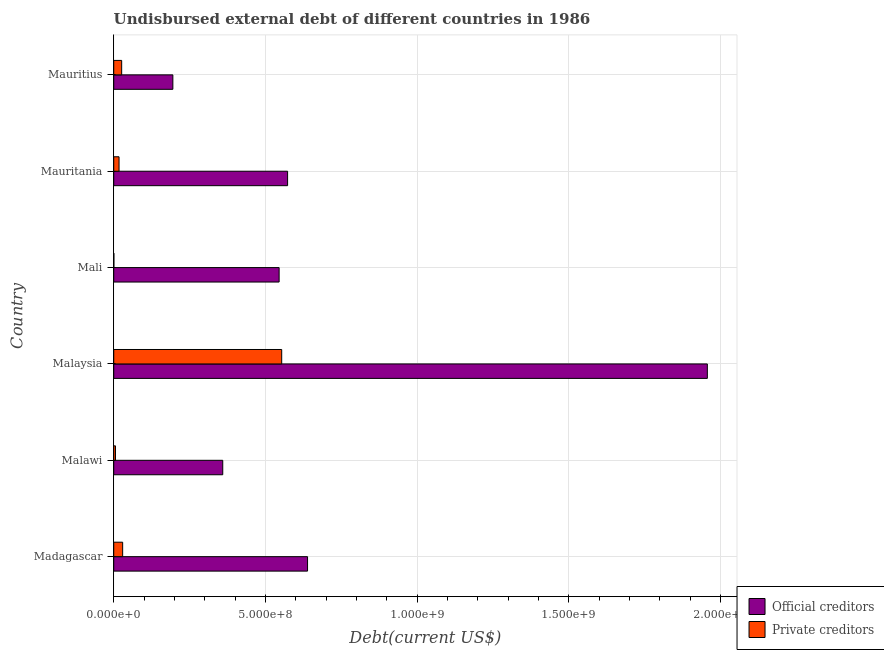How many different coloured bars are there?
Your response must be concise. 2. How many groups of bars are there?
Make the answer very short. 6. Are the number of bars per tick equal to the number of legend labels?
Make the answer very short. Yes. How many bars are there on the 6th tick from the bottom?
Offer a terse response. 2. What is the label of the 5th group of bars from the top?
Your response must be concise. Malawi. What is the undisbursed external debt of official creditors in Malaysia?
Offer a terse response. 1.96e+09. Across all countries, what is the maximum undisbursed external debt of official creditors?
Your answer should be compact. 1.96e+09. Across all countries, what is the minimum undisbursed external debt of private creditors?
Your answer should be very brief. 4.54e+05. In which country was the undisbursed external debt of private creditors maximum?
Offer a very short reply. Malaysia. In which country was the undisbursed external debt of private creditors minimum?
Your response must be concise. Mali. What is the total undisbursed external debt of private creditors in the graph?
Your answer should be compact. 6.33e+08. What is the difference between the undisbursed external debt of official creditors in Mauritania and that in Mauritius?
Give a very brief answer. 3.78e+08. What is the difference between the undisbursed external debt of official creditors in Mali and the undisbursed external debt of private creditors in Malaysia?
Make the answer very short. -8.51e+06. What is the average undisbursed external debt of private creditors per country?
Your answer should be very brief. 1.06e+08. What is the difference between the undisbursed external debt of official creditors and undisbursed external debt of private creditors in Mauritius?
Your response must be concise. 1.69e+08. In how many countries, is the undisbursed external debt of private creditors greater than 600000000 US$?
Provide a short and direct response. 0. What is the ratio of the undisbursed external debt of private creditors in Mali to that in Mauritania?
Provide a succinct answer. 0.03. Is the difference between the undisbursed external debt of official creditors in Malawi and Malaysia greater than the difference between the undisbursed external debt of private creditors in Malawi and Malaysia?
Offer a terse response. No. What is the difference between the highest and the second highest undisbursed external debt of private creditors?
Offer a terse response. 5.24e+08. What is the difference between the highest and the lowest undisbursed external debt of private creditors?
Your response must be concise. 5.53e+08. In how many countries, is the undisbursed external debt of official creditors greater than the average undisbursed external debt of official creditors taken over all countries?
Give a very brief answer. 1. What does the 1st bar from the top in Mauritania represents?
Provide a short and direct response. Private creditors. What does the 2nd bar from the bottom in Mali represents?
Your answer should be very brief. Private creditors. Are all the bars in the graph horizontal?
Make the answer very short. Yes. Does the graph contain any zero values?
Your response must be concise. No. Does the graph contain grids?
Your response must be concise. Yes. Where does the legend appear in the graph?
Provide a succinct answer. Bottom right. How many legend labels are there?
Provide a succinct answer. 2. What is the title of the graph?
Your answer should be very brief. Undisbursed external debt of different countries in 1986. What is the label or title of the X-axis?
Ensure brevity in your answer.  Debt(current US$). What is the label or title of the Y-axis?
Your answer should be compact. Country. What is the Debt(current US$) in Official creditors in Madagascar?
Keep it short and to the point. 6.39e+08. What is the Debt(current US$) of Private creditors in Madagascar?
Give a very brief answer. 2.94e+07. What is the Debt(current US$) of Official creditors in Malawi?
Ensure brevity in your answer.  3.59e+08. What is the Debt(current US$) of Private creditors in Malawi?
Make the answer very short. 5.76e+06. What is the Debt(current US$) in Official creditors in Malaysia?
Ensure brevity in your answer.  1.96e+09. What is the Debt(current US$) in Private creditors in Malaysia?
Keep it short and to the point. 5.54e+08. What is the Debt(current US$) of Official creditors in Mali?
Provide a succinct answer. 5.45e+08. What is the Debt(current US$) in Private creditors in Mali?
Your response must be concise. 4.54e+05. What is the Debt(current US$) in Official creditors in Mauritania?
Your answer should be very brief. 5.73e+08. What is the Debt(current US$) in Private creditors in Mauritania?
Ensure brevity in your answer.  1.75e+07. What is the Debt(current US$) of Official creditors in Mauritius?
Provide a succinct answer. 1.95e+08. What is the Debt(current US$) in Private creditors in Mauritius?
Your answer should be compact. 2.62e+07. Across all countries, what is the maximum Debt(current US$) of Official creditors?
Give a very brief answer. 1.96e+09. Across all countries, what is the maximum Debt(current US$) of Private creditors?
Provide a short and direct response. 5.54e+08. Across all countries, what is the minimum Debt(current US$) in Official creditors?
Ensure brevity in your answer.  1.95e+08. Across all countries, what is the minimum Debt(current US$) of Private creditors?
Make the answer very short. 4.54e+05. What is the total Debt(current US$) in Official creditors in the graph?
Ensure brevity in your answer.  4.27e+09. What is the total Debt(current US$) in Private creditors in the graph?
Offer a very short reply. 6.33e+08. What is the difference between the Debt(current US$) of Official creditors in Madagascar and that in Malawi?
Your answer should be very brief. 2.80e+08. What is the difference between the Debt(current US$) of Private creditors in Madagascar and that in Malawi?
Your answer should be very brief. 2.36e+07. What is the difference between the Debt(current US$) in Official creditors in Madagascar and that in Malaysia?
Your answer should be very brief. -1.32e+09. What is the difference between the Debt(current US$) of Private creditors in Madagascar and that in Malaysia?
Keep it short and to the point. -5.24e+08. What is the difference between the Debt(current US$) in Official creditors in Madagascar and that in Mali?
Your answer should be compact. 9.37e+07. What is the difference between the Debt(current US$) of Private creditors in Madagascar and that in Mali?
Your answer should be compact. 2.89e+07. What is the difference between the Debt(current US$) of Official creditors in Madagascar and that in Mauritania?
Make the answer very short. 6.58e+07. What is the difference between the Debt(current US$) in Private creditors in Madagascar and that in Mauritania?
Keep it short and to the point. 1.19e+07. What is the difference between the Debt(current US$) of Official creditors in Madagascar and that in Mauritius?
Provide a short and direct response. 4.44e+08. What is the difference between the Debt(current US$) of Private creditors in Madagascar and that in Mauritius?
Provide a succinct answer. 3.24e+06. What is the difference between the Debt(current US$) in Official creditors in Malawi and that in Malaysia?
Your answer should be very brief. -1.60e+09. What is the difference between the Debt(current US$) in Private creditors in Malawi and that in Malaysia?
Your answer should be compact. -5.48e+08. What is the difference between the Debt(current US$) in Official creditors in Malawi and that in Mali?
Provide a succinct answer. -1.86e+08. What is the difference between the Debt(current US$) of Private creditors in Malawi and that in Mali?
Offer a very short reply. 5.31e+06. What is the difference between the Debt(current US$) of Official creditors in Malawi and that in Mauritania?
Your response must be concise. -2.14e+08. What is the difference between the Debt(current US$) of Private creditors in Malawi and that in Mauritania?
Ensure brevity in your answer.  -1.17e+07. What is the difference between the Debt(current US$) of Official creditors in Malawi and that in Mauritius?
Ensure brevity in your answer.  1.64e+08. What is the difference between the Debt(current US$) of Private creditors in Malawi and that in Mauritius?
Offer a terse response. -2.04e+07. What is the difference between the Debt(current US$) in Official creditors in Malaysia and that in Mali?
Offer a terse response. 1.41e+09. What is the difference between the Debt(current US$) in Private creditors in Malaysia and that in Mali?
Make the answer very short. 5.53e+08. What is the difference between the Debt(current US$) of Official creditors in Malaysia and that in Mauritania?
Provide a succinct answer. 1.38e+09. What is the difference between the Debt(current US$) of Private creditors in Malaysia and that in Mauritania?
Your answer should be compact. 5.36e+08. What is the difference between the Debt(current US$) of Official creditors in Malaysia and that in Mauritius?
Keep it short and to the point. 1.76e+09. What is the difference between the Debt(current US$) in Private creditors in Malaysia and that in Mauritius?
Provide a succinct answer. 5.28e+08. What is the difference between the Debt(current US$) in Official creditors in Mali and that in Mauritania?
Provide a succinct answer. -2.79e+07. What is the difference between the Debt(current US$) in Private creditors in Mali and that in Mauritania?
Provide a short and direct response. -1.71e+07. What is the difference between the Debt(current US$) in Official creditors in Mali and that in Mauritius?
Offer a terse response. 3.50e+08. What is the difference between the Debt(current US$) of Private creditors in Mali and that in Mauritius?
Your answer should be very brief. -2.57e+07. What is the difference between the Debt(current US$) in Official creditors in Mauritania and that in Mauritius?
Keep it short and to the point. 3.78e+08. What is the difference between the Debt(current US$) in Private creditors in Mauritania and that in Mauritius?
Your answer should be very brief. -8.66e+06. What is the difference between the Debt(current US$) in Official creditors in Madagascar and the Debt(current US$) in Private creditors in Malawi?
Give a very brief answer. 6.33e+08. What is the difference between the Debt(current US$) of Official creditors in Madagascar and the Debt(current US$) of Private creditors in Malaysia?
Keep it short and to the point. 8.52e+07. What is the difference between the Debt(current US$) of Official creditors in Madagascar and the Debt(current US$) of Private creditors in Mali?
Give a very brief answer. 6.38e+08. What is the difference between the Debt(current US$) in Official creditors in Madagascar and the Debt(current US$) in Private creditors in Mauritania?
Provide a short and direct response. 6.21e+08. What is the difference between the Debt(current US$) of Official creditors in Madagascar and the Debt(current US$) of Private creditors in Mauritius?
Provide a short and direct response. 6.13e+08. What is the difference between the Debt(current US$) of Official creditors in Malawi and the Debt(current US$) of Private creditors in Malaysia?
Give a very brief answer. -1.94e+08. What is the difference between the Debt(current US$) of Official creditors in Malawi and the Debt(current US$) of Private creditors in Mali?
Ensure brevity in your answer.  3.59e+08. What is the difference between the Debt(current US$) of Official creditors in Malawi and the Debt(current US$) of Private creditors in Mauritania?
Provide a succinct answer. 3.42e+08. What is the difference between the Debt(current US$) in Official creditors in Malawi and the Debt(current US$) in Private creditors in Mauritius?
Provide a succinct answer. 3.33e+08. What is the difference between the Debt(current US$) of Official creditors in Malaysia and the Debt(current US$) of Private creditors in Mali?
Your response must be concise. 1.96e+09. What is the difference between the Debt(current US$) in Official creditors in Malaysia and the Debt(current US$) in Private creditors in Mauritania?
Your answer should be compact. 1.94e+09. What is the difference between the Debt(current US$) of Official creditors in Malaysia and the Debt(current US$) of Private creditors in Mauritius?
Provide a succinct answer. 1.93e+09. What is the difference between the Debt(current US$) of Official creditors in Mali and the Debt(current US$) of Private creditors in Mauritania?
Give a very brief answer. 5.28e+08. What is the difference between the Debt(current US$) in Official creditors in Mali and the Debt(current US$) in Private creditors in Mauritius?
Make the answer very short. 5.19e+08. What is the difference between the Debt(current US$) of Official creditors in Mauritania and the Debt(current US$) of Private creditors in Mauritius?
Your answer should be compact. 5.47e+08. What is the average Debt(current US$) of Official creditors per country?
Offer a terse response. 7.11e+08. What is the average Debt(current US$) in Private creditors per country?
Make the answer very short. 1.06e+08. What is the difference between the Debt(current US$) in Official creditors and Debt(current US$) in Private creditors in Madagascar?
Your response must be concise. 6.10e+08. What is the difference between the Debt(current US$) of Official creditors and Debt(current US$) of Private creditors in Malawi?
Offer a very short reply. 3.54e+08. What is the difference between the Debt(current US$) in Official creditors and Debt(current US$) in Private creditors in Malaysia?
Make the answer very short. 1.40e+09. What is the difference between the Debt(current US$) of Official creditors and Debt(current US$) of Private creditors in Mali?
Your answer should be compact. 5.45e+08. What is the difference between the Debt(current US$) in Official creditors and Debt(current US$) in Private creditors in Mauritania?
Give a very brief answer. 5.56e+08. What is the difference between the Debt(current US$) in Official creditors and Debt(current US$) in Private creditors in Mauritius?
Ensure brevity in your answer.  1.69e+08. What is the ratio of the Debt(current US$) of Official creditors in Madagascar to that in Malawi?
Keep it short and to the point. 1.78. What is the ratio of the Debt(current US$) in Private creditors in Madagascar to that in Malawi?
Your answer should be very brief. 5.1. What is the ratio of the Debt(current US$) in Official creditors in Madagascar to that in Malaysia?
Your answer should be very brief. 0.33. What is the ratio of the Debt(current US$) in Private creditors in Madagascar to that in Malaysia?
Keep it short and to the point. 0.05. What is the ratio of the Debt(current US$) in Official creditors in Madagascar to that in Mali?
Give a very brief answer. 1.17. What is the ratio of the Debt(current US$) of Private creditors in Madagascar to that in Mali?
Make the answer very short. 64.76. What is the ratio of the Debt(current US$) in Official creditors in Madagascar to that in Mauritania?
Provide a short and direct response. 1.11. What is the ratio of the Debt(current US$) in Private creditors in Madagascar to that in Mauritania?
Offer a terse response. 1.68. What is the ratio of the Debt(current US$) in Official creditors in Madagascar to that in Mauritius?
Your answer should be very brief. 3.28. What is the ratio of the Debt(current US$) in Private creditors in Madagascar to that in Mauritius?
Your answer should be very brief. 1.12. What is the ratio of the Debt(current US$) of Official creditors in Malawi to that in Malaysia?
Your answer should be compact. 0.18. What is the ratio of the Debt(current US$) in Private creditors in Malawi to that in Malaysia?
Your answer should be compact. 0.01. What is the ratio of the Debt(current US$) in Official creditors in Malawi to that in Mali?
Give a very brief answer. 0.66. What is the ratio of the Debt(current US$) in Private creditors in Malawi to that in Mali?
Make the answer very short. 12.7. What is the ratio of the Debt(current US$) of Official creditors in Malawi to that in Mauritania?
Provide a succinct answer. 0.63. What is the ratio of the Debt(current US$) in Private creditors in Malawi to that in Mauritania?
Offer a terse response. 0.33. What is the ratio of the Debt(current US$) in Official creditors in Malawi to that in Mauritius?
Make the answer very short. 1.84. What is the ratio of the Debt(current US$) of Private creditors in Malawi to that in Mauritius?
Make the answer very short. 0.22. What is the ratio of the Debt(current US$) of Official creditors in Malaysia to that in Mali?
Your answer should be very brief. 3.59. What is the ratio of the Debt(current US$) of Private creditors in Malaysia to that in Mali?
Keep it short and to the point. 1219.67. What is the ratio of the Debt(current US$) of Official creditors in Malaysia to that in Mauritania?
Give a very brief answer. 3.41. What is the ratio of the Debt(current US$) of Private creditors in Malaysia to that in Mauritania?
Offer a very short reply. 31.63. What is the ratio of the Debt(current US$) in Official creditors in Malaysia to that in Mauritius?
Provide a short and direct response. 10.04. What is the ratio of the Debt(current US$) of Private creditors in Malaysia to that in Mauritius?
Offer a terse response. 21.17. What is the ratio of the Debt(current US$) in Official creditors in Mali to that in Mauritania?
Make the answer very short. 0.95. What is the ratio of the Debt(current US$) of Private creditors in Mali to that in Mauritania?
Offer a terse response. 0.03. What is the ratio of the Debt(current US$) of Official creditors in Mali to that in Mauritius?
Offer a terse response. 2.8. What is the ratio of the Debt(current US$) in Private creditors in Mali to that in Mauritius?
Your response must be concise. 0.02. What is the ratio of the Debt(current US$) of Official creditors in Mauritania to that in Mauritius?
Provide a succinct answer. 2.94. What is the ratio of the Debt(current US$) of Private creditors in Mauritania to that in Mauritius?
Your answer should be compact. 0.67. What is the difference between the highest and the second highest Debt(current US$) of Official creditors?
Your response must be concise. 1.32e+09. What is the difference between the highest and the second highest Debt(current US$) of Private creditors?
Your response must be concise. 5.24e+08. What is the difference between the highest and the lowest Debt(current US$) in Official creditors?
Your answer should be compact. 1.76e+09. What is the difference between the highest and the lowest Debt(current US$) of Private creditors?
Your answer should be compact. 5.53e+08. 